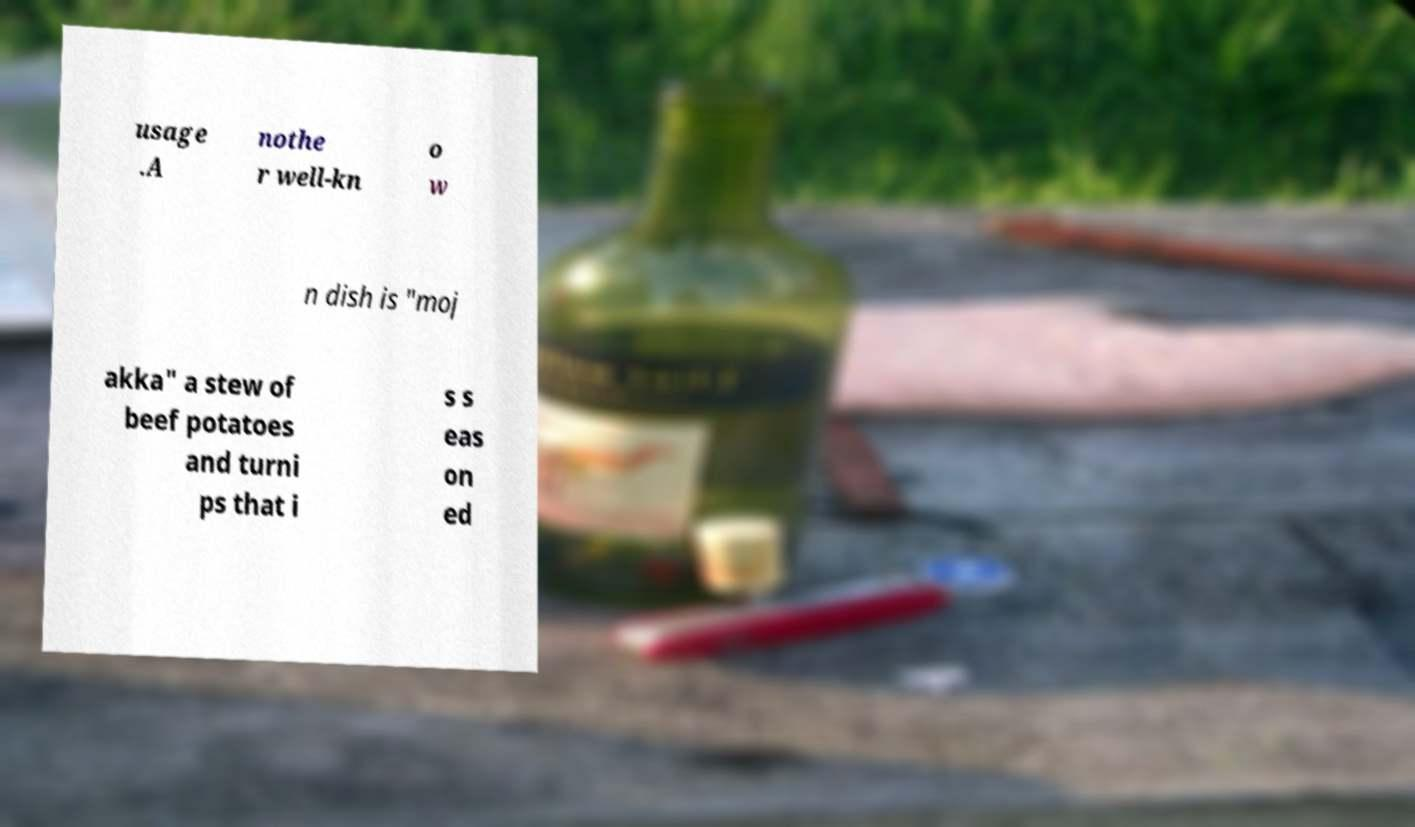Please identify and transcribe the text found in this image. usage .A nothe r well-kn o w n dish is "moj akka" a stew of beef potatoes and turni ps that i s s eas on ed 